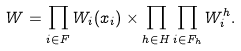Convert formula to latex. <formula><loc_0><loc_0><loc_500><loc_500>W = \prod _ { i \in F } W _ { i } ( x _ { i } ) \times \prod _ { h \in H } \prod _ { i \in F _ { h } } W _ { i } ^ { h } .</formula> 